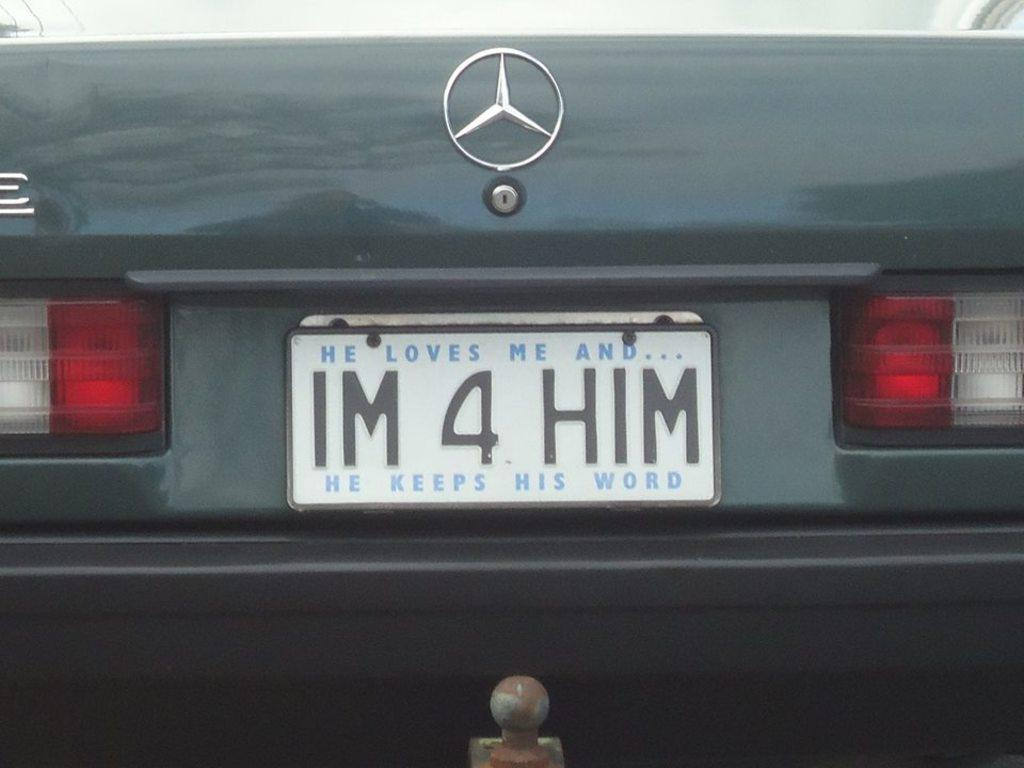Provide a one-sentence caption for the provided image. A license plate that says IM 4 HIM on the back of a car. 